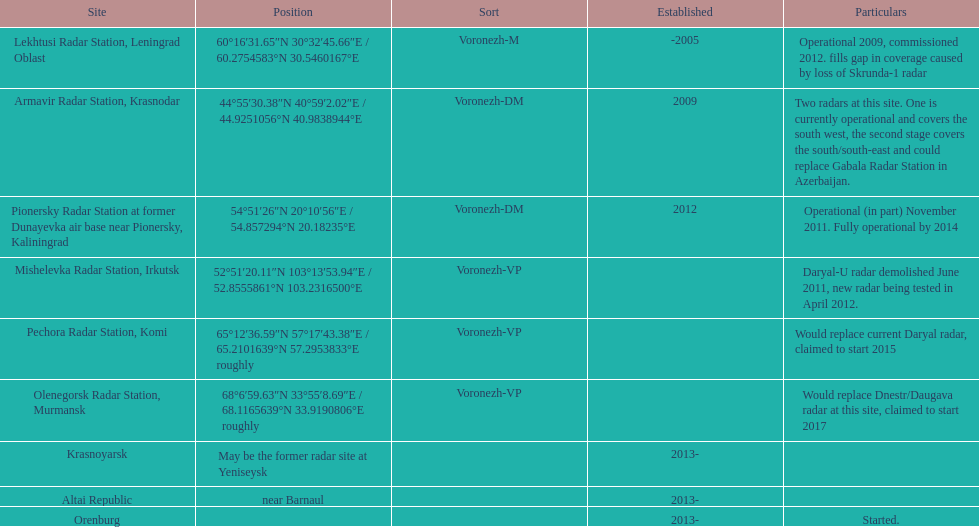How many voronezh radars are in kaliningrad or in krasnodar? 2. 